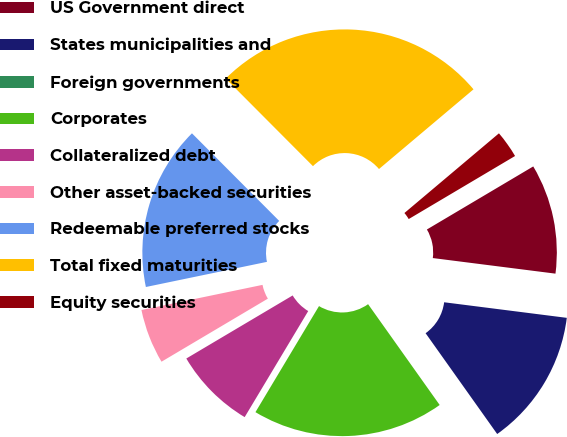<chart> <loc_0><loc_0><loc_500><loc_500><pie_chart><fcel>US Government direct<fcel>States municipalities and<fcel>Foreign governments<fcel>Corporates<fcel>Collateralized debt<fcel>Other asset-backed securities<fcel>Redeemable preferred stocks<fcel>Total fixed maturities<fcel>Equity securities<nl><fcel>10.53%<fcel>13.16%<fcel>0.0%<fcel>18.42%<fcel>7.89%<fcel>5.26%<fcel>15.79%<fcel>26.32%<fcel>2.63%<nl></chart> 